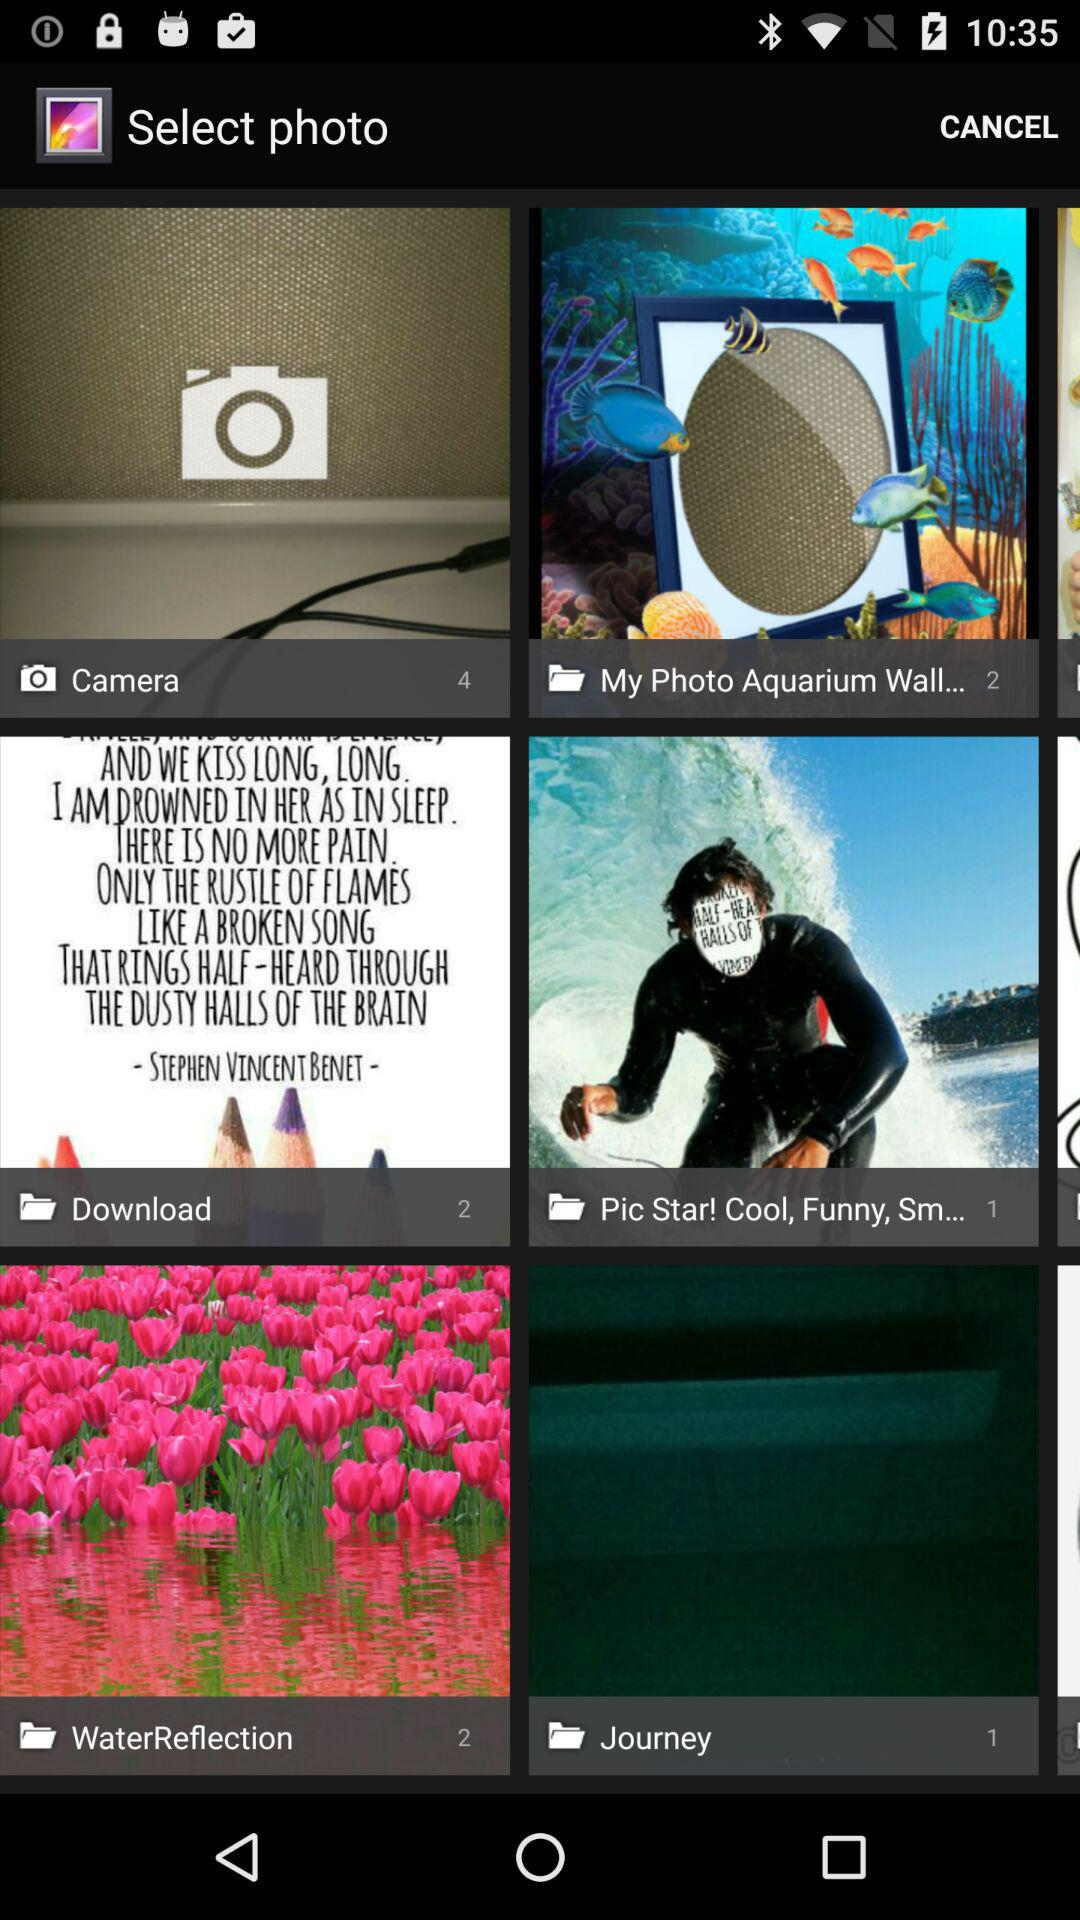How many pictures are available in the download folder? There are 2 pictures available in the download folder. 